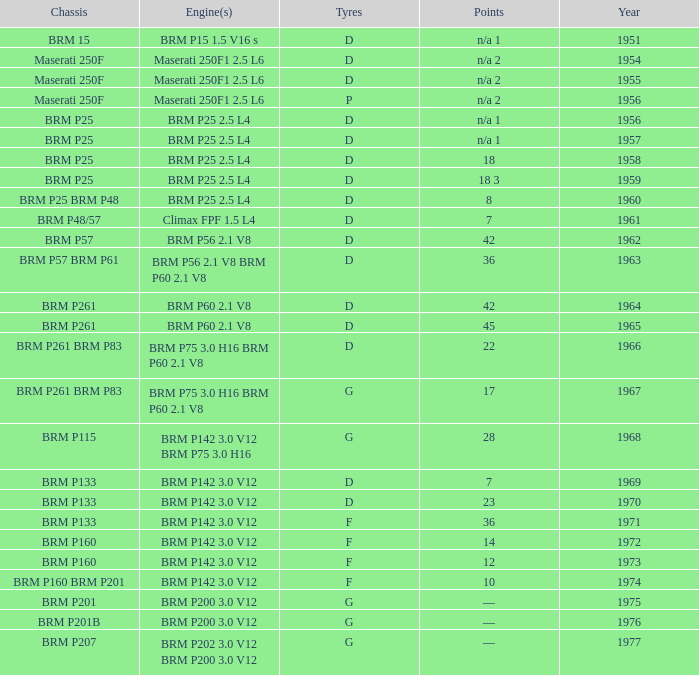Name the point for 1974 10.0. 